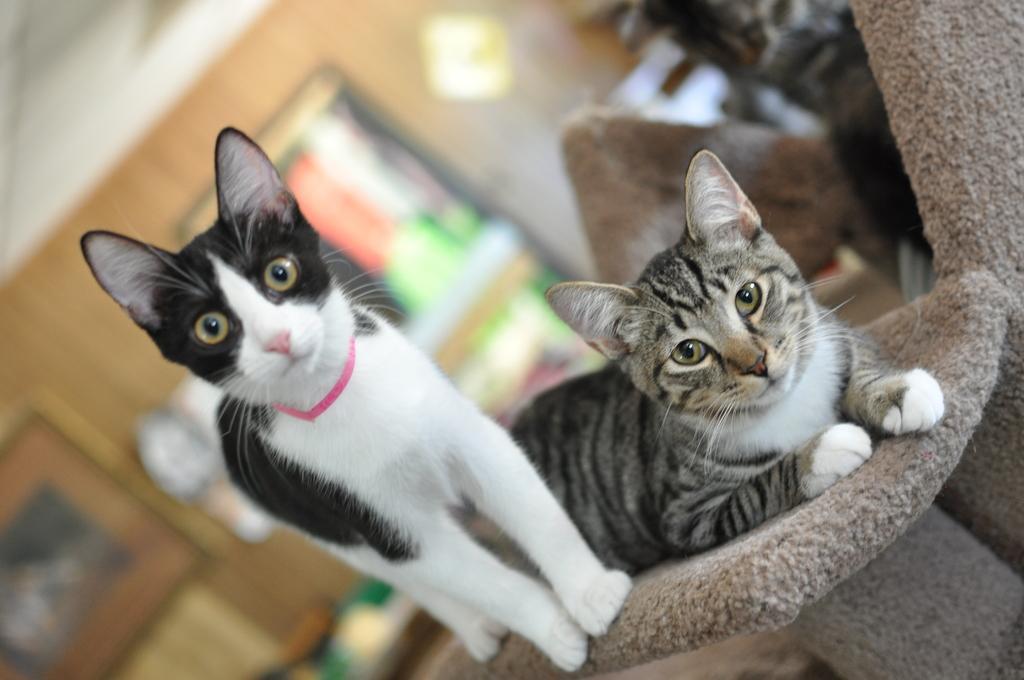Can you describe this image briefly? In this picture we can see two cats on an object. There are a few objects visible in the background. Background is blurry. 